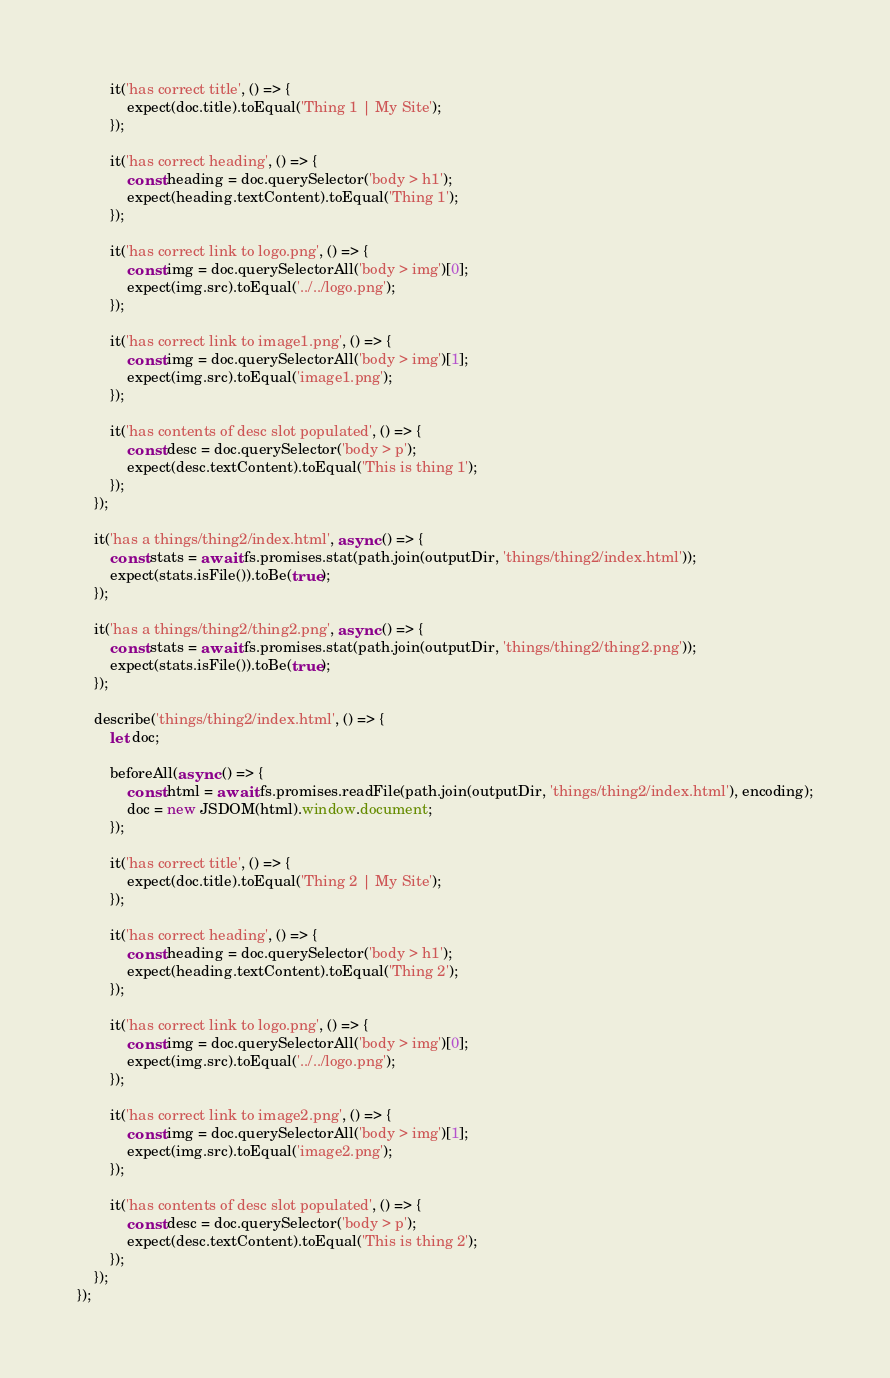<code> <loc_0><loc_0><loc_500><loc_500><_JavaScript_>        it('has correct title', () => {
            expect(doc.title).toEqual('Thing 1 | My Site');
        });

        it('has correct heading', () => {
            const heading = doc.querySelector('body > h1');
            expect(heading.textContent).toEqual('Thing 1');
        });

        it('has correct link to logo.png', () => {
            const img = doc.querySelectorAll('body > img')[0];
            expect(img.src).toEqual('../../logo.png');
        });

        it('has correct link to image1.png', () => {
            const img = doc.querySelectorAll('body > img')[1];
            expect(img.src).toEqual('image1.png');
        });

        it('has contents of desc slot populated', () => {
            const desc = doc.querySelector('body > p');
            expect(desc.textContent).toEqual('This is thing 1');
        });
    });
    
    it('has a things/thing2/index.html', async () => {
        const stats = await fs.promises.stat(path.join(outputDir, 'things/thing2/index.html'));
        expect(stats.isFile()).toBe(true);
    });
    
    it('has a things/thing2/thing2.png', async () => {
        const stats = await fs.promises.stat(path.join(outputDir, 'things/thing2/thing2.png'));
        expect(stats.isFile()).toBe(true);
    });

    describe('things/thing2/index.html', () => {
        let doc;

        beforeAll(async () => {
            const html = await fs.promises.readFile(path.join(outputDir, 'things/thing2/index.html'), encoding);
            doc = new JSDOM(html).window.document;
        });

        it('has correct title', () => {
            expect(doc.title).toEqual('Thing 2 | My Site');
        });

        it('has correct heading', () => {
            const heading = doc.querySelector('body > h1');
            expect(heading.textContent).toEqual('Thing 2');
        });

        it('has correct link to logo.png', () => {
            const img = doc.querySelectorAll('body > img')[0];
            expect(img.src).toEqual('../../logo.png');
        });

        it('has correct link to image2.png', () => {
            const img = doc.querySelectorAll('body > img')[1];
            expect(img.src).toEqual('image2.png');
        });

        it('has contents of desc slot populated', () => {
            const desc = doc.querySelector('body > p');
            expect(desc.textContent).toEqual('This is thing 2');
        });
    });
});</code> 